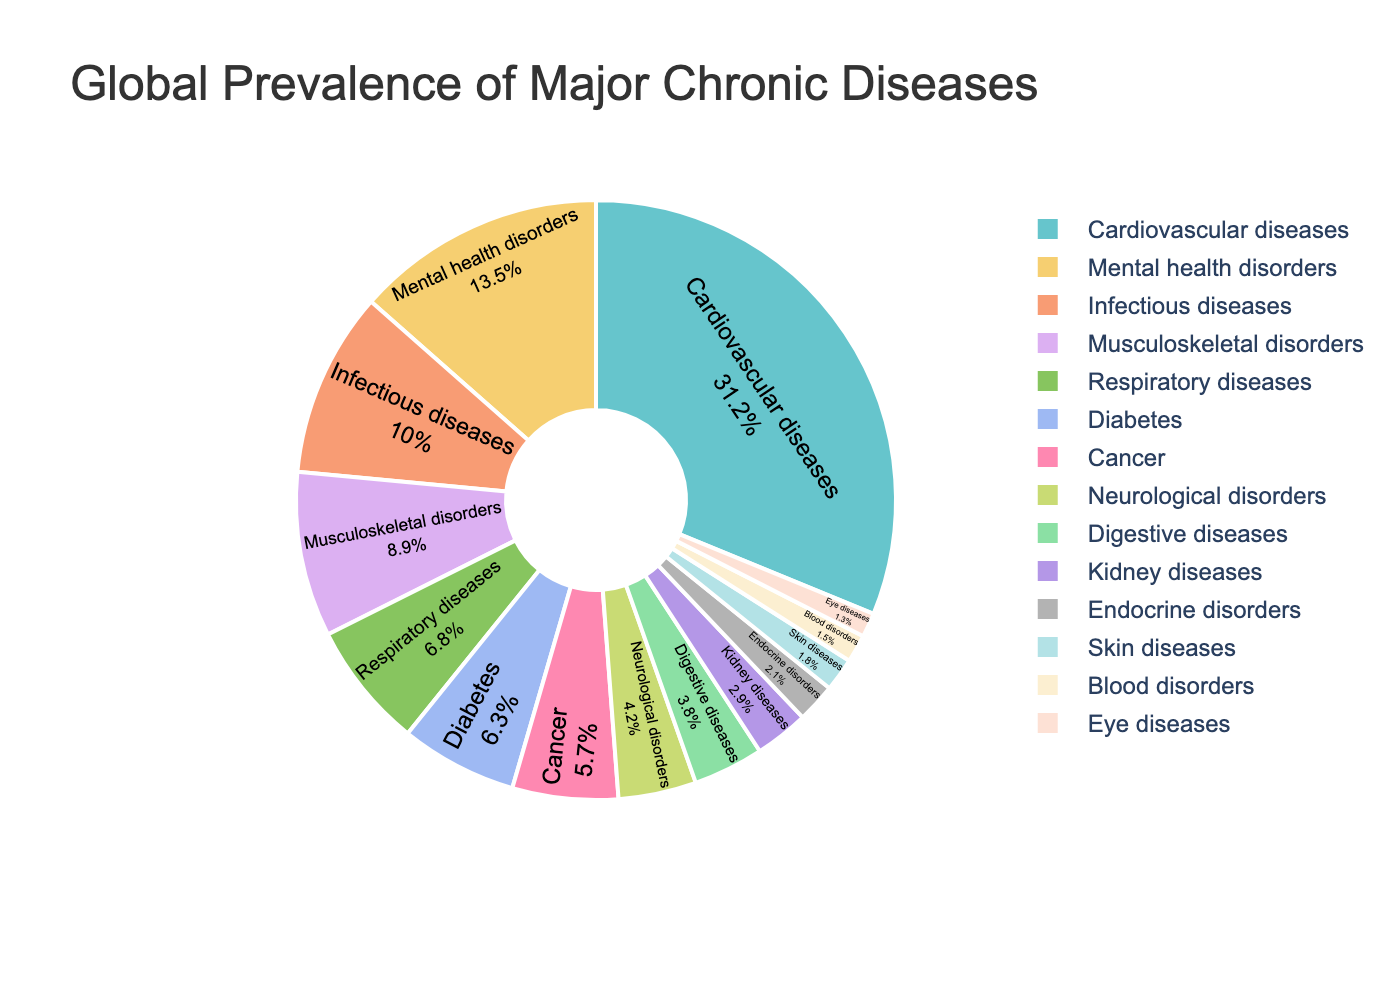Which disease has the highest global prevalence? The disease with the highest percentage value in the pie chart represents the highest global prevalence. Cardiovascular diseases are at 31.2%, which is the largest segment.
Answer: Cardiovascular diseases What are the combined prevalence percentages of Respiratory diseases and Diabetes? Find Respiratory diseases' prevalence (6.8%) and Diabetes (6.3%), then sum them up: 6.8 + 6.3 = 13.1.
Answer: 13.1% Is the prevalence of Cancer greater than that of Neurological disorders? Compare the prevalence values of Cancer (5.7%) and Neurological disorders (4.2%). Since 5.7% is greater than 4.2%, Cancer's prevalence is indeed higher.
Answer: Yes Which types of diseases have a prevalence lower than 2%? Identify the disease segments with percentages less than 2%. Blood disorders (1.5%), Eye diseases (1.3%), and Skin diseases (1.8%) all fall below 2%.
Answer: Blood disorders, Eye diseases, and Skin diseases What is the percentage difference between Musculoskeletal disorders and Digestive diseases? Subtract the prevalence of Digestive diseases (3.8%) from Musculoskeletal disorders (8.9%): 8.9 - 3.8 = 5.1.
Answer: 5.1% What color is the segment representing Infectious diseases? Identify the segment corresponding to Infectious diseases, which is usually color-coded, likely in a chart with a label indicating the color.
Answer: Varies (depends on the palette used, assumed as Pastel tones) Which has a higher prevalence: Endocrine disorders or Kidney diseases, and by how much? Compare Endocrine disorders (2.1%) and Kidney diseases (2.9%) and calculate the difference: 2.9 - 2.1 = 0.8.
Answer: Kidney diseases by 0.8% Rank the diseases that have a prevalence above 10% in descending order. List diseases greater than 10%, which are Cardiovascular diseases (31.2%), Mental health disorders (13.5%), and Infectious diseases (10%). Ordered: Cardiovascular diseases, Mental health disorders, Infectious diseases.
Answer: Cardiovascular diseases, Mental health disorders, Infectious diseases What's the total percentage of the least common four diseases? Sum the prevalence of the least common four diseases: Eye diseases (1.3%), Blood disorders (1.5%), Skin diseases (1.8%), and Endocrine disorders (2.1%): 1.3 + 1.5 + 1.8 + 2.1 = 6.7.
Answer: 6.7% Are Mental health disorders more prevalent than Diabetes and Cancer combined? Sum the prevalence of Diabetes (6.3%) and Cancer (5.7%): 6.3 + 5.7 = 12. Mental health disorders are at 13.5%, which is greater than 12%.
Answer: Yes 